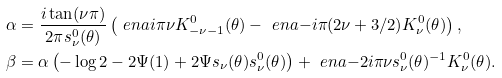<formula> <loc_0><loc_0><loc_500><loc_500>& \alpha = \frac { i \tan ( \nu \pi ) } { 2 \pi s ^ { 0 } _ { \nu } ( \theta ) } \left ( \ e n a { i \pi \nu } K ^ { 0 } _ { - \nu - 1 } ( \theta ) - \ e n a { - i \pi ( 2 \nu + 3 / 2 ) } K ^ { 0 } _ { \nu } ( \theta ) \right ) , \\ & \beta = \alpha \left ( - \log 2 - 2 \Psi ( 1 ) + 2 \Psi s _ { \nu } ( \theta ) s ^ { 0 } _ { \nu } ( \theta ) \right ) + \ e n a { - 2 i \pi \nu } s ^ { 0 } _ { \nu } ( \theta ) ^ { - 1 } K ^ { 0 } _ { \nu } ( \theta ) .</formula> 